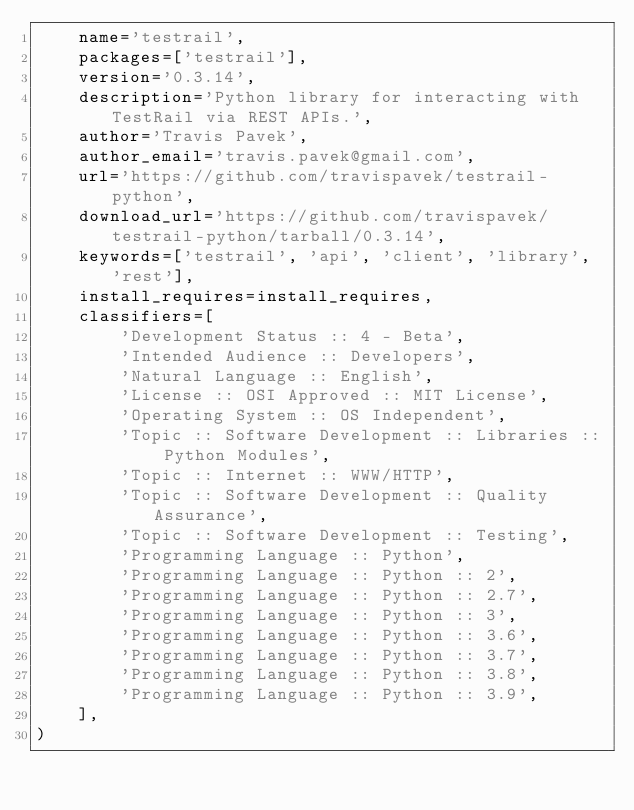<code> <loc_0><loc_0><loc_500><loc_500><_Python_>    name='testrail',
    packages=['testrail'],
    version='0.3.14',
    description='Python library for interacting with TestRail via REST APIs.',
    author='Travis Pavek',
    author_email='travis.pavek@gmail.com',
    url='https://github.com/travispavek/testrail-python',
    download_url='https://github.com/travispavek/testrail-python/tarball/0.3.14',
    keywords=['testrail', 'api', 'client', 'library', 'rest'],
    install_requires=install_requires,
    classifiers=[
        'Development Status :: 4 - Beta',
        'Intended Audience :: Developers',
        'Natural Language :: English',
        'License :: OSI Approved :: MIT License',
        'Operating System :: OS Independent',
        'Topic :: Software Development :: Libraries :: Python Modules',
        'Topic :: Internet :: WWW/HTTP',
        'Topic :: Software Development :: Quality Assurance',
        'Topic :: Software Development :: Testing',
        'Programming Language :: Python',
        'Programming Language :: Python :: 2',
        'Programming Language :: Python :: 2.7',
        'Programming Language :: Python :: 3',
        'Programming Language :: Python :: 3.6',
        'Programming Language :: Python :: 3.7',
        'Programming Language :: Python :: 3.8',
        'Programming Language :: Python :: 3.9',
    ],
)
</code> 